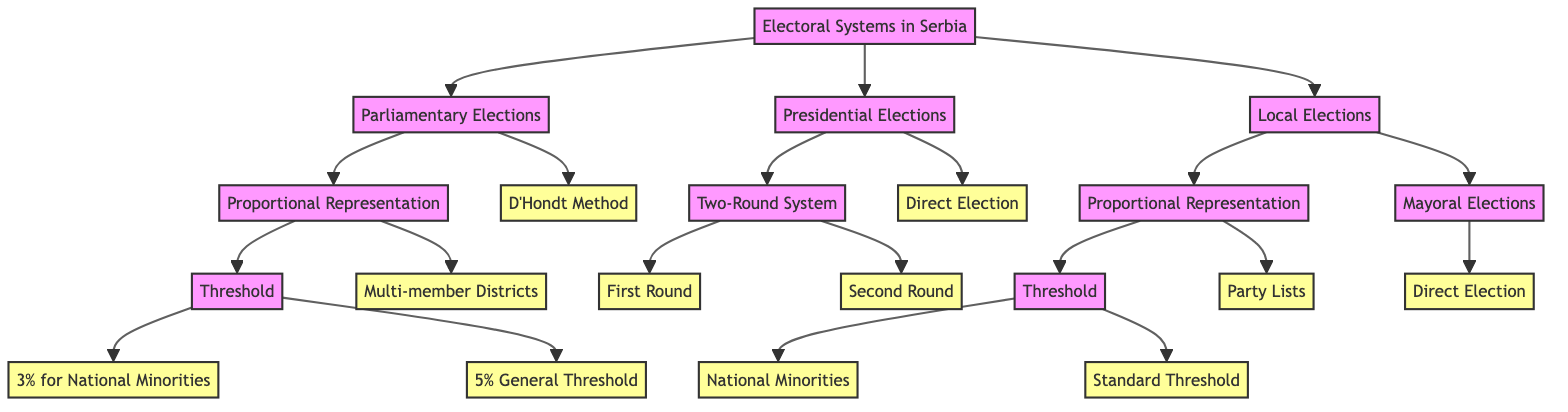What are the three main categories of elections in Serbia according to the diagram? The diagram lists three main categories of elections: Parliamentary Elections, Presidential Elections, and Local Elections. These are the primary nodes stemming from the root node titled "Electoral Systems in Serbia."
Answer: Parliamentary Elections, Presidential Elections, Local Elections What is the threshold percentage for national minorities in parliamentary elections? According to the diagram, the threshold for national minorities in parliamentary elections is set at 3%. This is indicated in the "Threshold" node under the "Proportional Representation" branch of the "Parliamentary Elections."
Answer: 3% How many methods of representing parties are there in local elections as per the diagram? The diagram shows that there are two methods of representing parties in local elections: Proportional Representation and Mayoral Elections. Therefore, this counts as two distinct methods.
Answer: 2 What is the outcome of the D'Hondt Method in parliamentary elections? The diagram states that the outcome of the D'Hondt Method is the allocation of seats using this method to ensure proportional representation. This is a specific outcome associated with the "D'Hondt Method" node under "Parliamentary Elections."
Answer: Seats allocated using the D'Hondt method In the presidential election process, what happens in the second round if a majority is not achieved in the first round? The diagram indicates that if no majority is achieved in the first round, the top two candidates from that round compete again in the second round. This process is depicted in the "Two-Round System" branch of the "Presidential Elections."
Answer: Top two candidates compete again What kind of elections do local mayors undergo according to the diagram? The diagram specifies that local mayors are elected through a direct election process. This is illustrated under the "Mayoral Elections" node in the "Local Elections" category.
Answer: Direct Election What signifies the "Multi-member Districts" node in the context of parliamentary elections? The "Multi-member Districts" node indicates that elections in parliamentary elections are held in multiple districts, where each district contributes to parliament proportionally. This explains its role under the "Proportional Representation" branch in "Parliamentary Elections."
Answer: Elections are held in multiple districts What is the term used for the first round of presidential elections? The term used for the first round of presidential elections is "First Round." This is highlighted in the "Two-Round System" branch, indicating the initial stage of the presidential election process.
Answer: First Round 